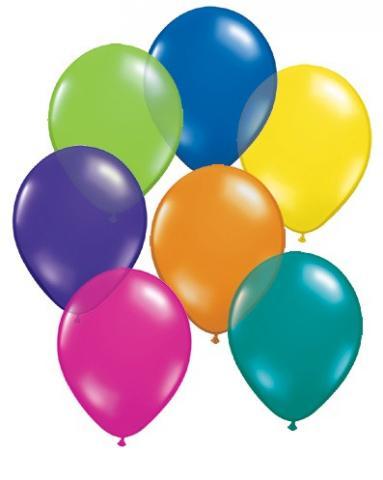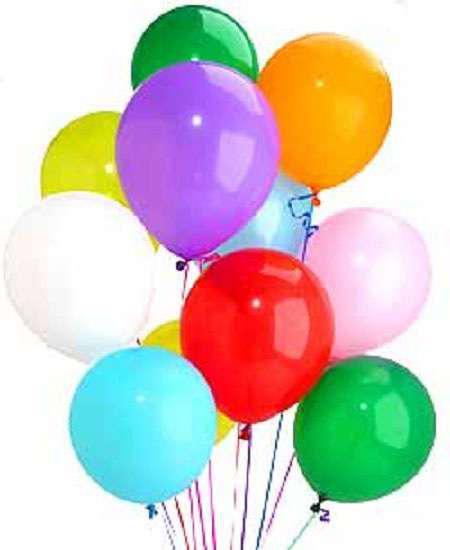The first image is the image on the left, the second image is the image on the right. Analyze the images presented: Is the assertion "The left and right image contains a bushel of balloons with strings and at least two balloons are green," valid? Answer yes or no. No. The first image is the image on the left, the second image is the image on the right. Evaluate the accuracy of this statement regarding the images: "The right image has exactly eleven balloons". Is it true? Answer yes or no. Yes. 